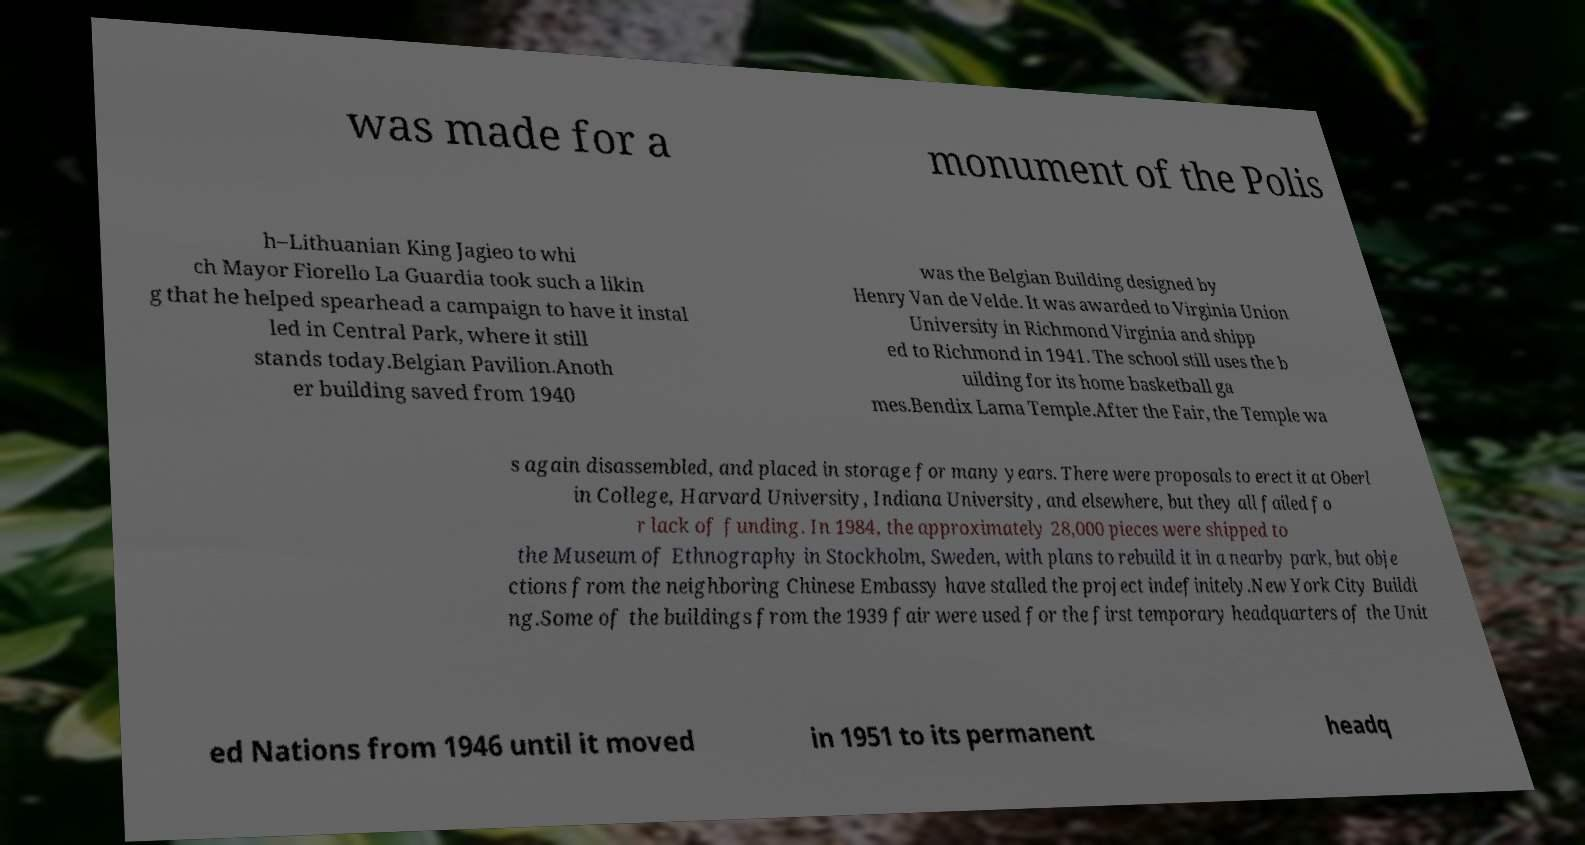Can you read and provide the text displayed in the image?This photo seems to have some interesting text. Can you extract and type it out for me? was made for a monument of the Polis h–Lithuanian King Jagieo to whi ch Mayor Fiorello La Guardia took such a likin g that he helped spearhead a campaign to have it instal led in Central Park, where it still stands today.Belgian Pavilion.Anoth er building saved from 1940 was the Belgian Building designed by Henry Van de Velde. It was awarded to Virginia Union University in Richmond Virginia and shipp ed to Richmond in 1941. The school still uses the b uilding for its home basketball ga mes.Bendix Lama Temple.After the Fair, the Temple wa s again disassembled, and placed in storage for many years. There were proposals to erect it at Oberl in College, Harvard University, Indiana University, and elsewhere, but they all failed fo r lack of funding. In 1984, the approximately 28,000 pieces were shipped to the Museum of Ethnography in Stockholm, Sweden, with plans to rebuild it in a nearby park, but obje ctions from the neighboring Chinese Embassy have stalled the project indefinitely.New York City Buildi ng.Some of the buildings from the 1939 fair were used for the first temporary headquarters of the Unit ed Nations from 1946 until it moved in 1951 to its permanent headq 